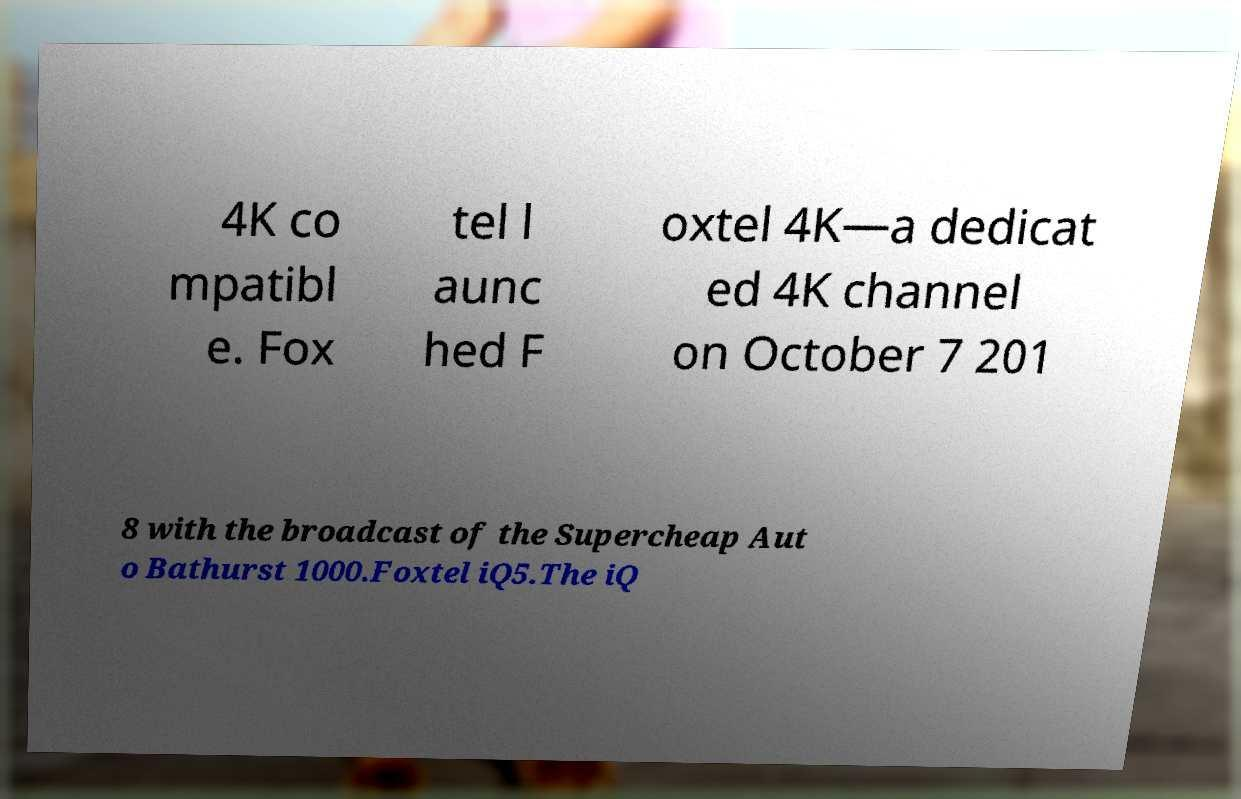I need the written content from this picture converted into text. Can you do that? 4K co mpatibl e. Fox tel l aunc hed F oxtel 4K—a dedicat ed 4K channel on October 7 201 8 with the broadcast of the Supercheap Aut o Bathurst 1000.Foxtel iQ5.The iQ 